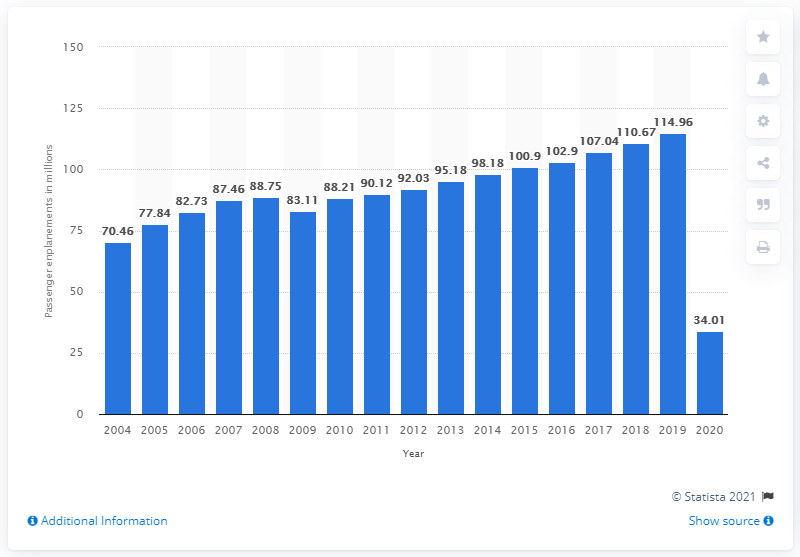Draw attention to some important aspects in this diagram. In 2020, U.S. airlines carried a total of 34.01 million passengers on international flights. 